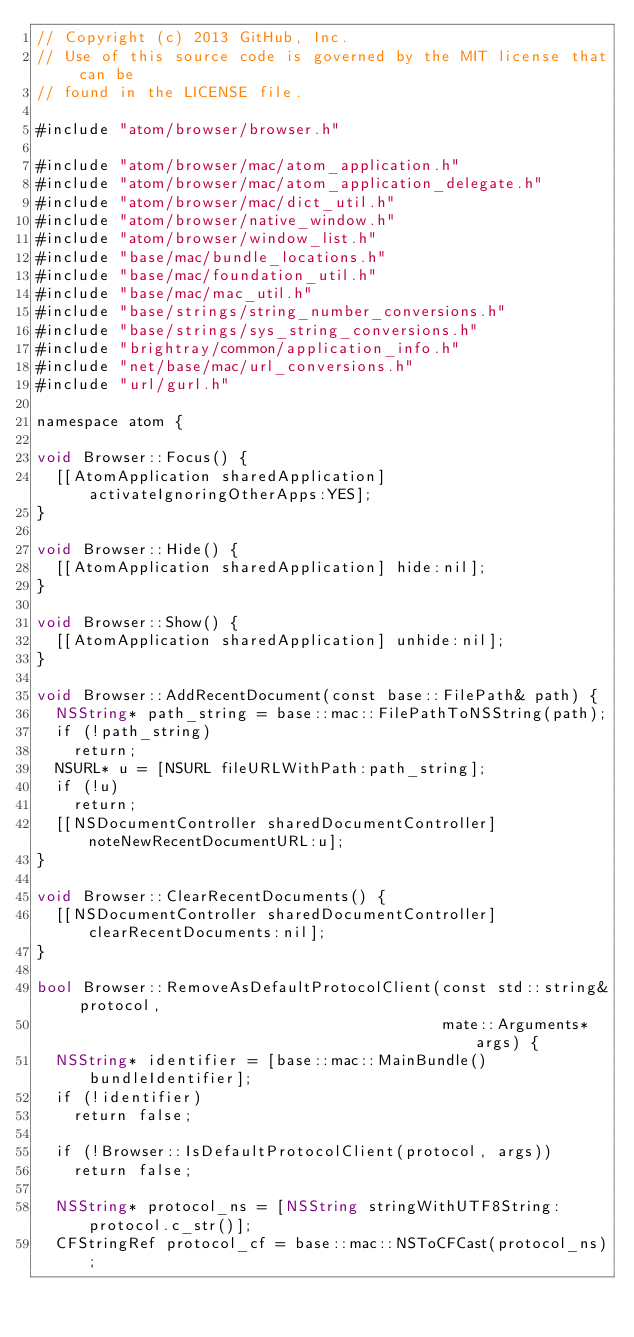<code> <loc_0><loc_0><loc_500><loc_500><_ObjectiveC_>// Copyright (c) 2013 GitHub, Inc.
// Use of this source code is governed by the MIT license that can be
// found in the LICENSE file.

#include "atom/browser/browser.h"

#include "atom/browser/mac/atom_application.h"
#include "atom/browser/mac/atom_application_delegate.h"
#include "atom/browser/mac/dict_util.h"
#include "atom/browser/native_window.h"
#include "atom/browser/window_list.h"
#include "base/mac/bundle_locations.h"
#include "base/mac/foundation_util.h"
#include "base/mac/mac_util.h"
#include "base/strings/string_number_conversions.h"
#include "base/strings/sys_string_conversions.h"
#include "brightray/common/application_info.h"
#include "net/base/mac/url_conversions.h"
#include "url/gurl.h"

namespace atom {

void Browser::Focus() {
  [[AtomApplication sharedApplication] activateIgnoringOtherApps:YES];
}

void Browser::Hide() {
  [[AtomApplication sharedApplication] hide:nil];
}

void Browser::Show() {
  [[AtomApplication sharedApplication] unhide:nil];
}

void Browser::AddRecentDocument(const base::FilePath& path) {
  NSString* path_string = base::mac::FilePathToNSString(path);
  if (!path_string)
    return;
  NSURL* u = [NSURL fileURLWithPath:path_string];
  if (!u)
    return;
  [[NSDocumentController sharedDocumentController] noteNewRecentDocumentURL:u];
}

void Browser::ClearRecentDocuments() {
  [[NSDocumentController sharedDocumentController] clearRecentDocuments:nil];
}

bool Browser::RemoveAsDefaultProtocolClient(const std::string& protocol,
                                            mate::Arguments* args) {
  NSString* identifier = [base::mac::MainBundle() bundleIdentifier];
  if (!identifier)
    return false;

  if (!Browser::IsDefaultProtocolClient(protocol, args))
    return false;

  NSString* protocol_ns = [NSString stringWithUTF8String:protocol.c_str()];
  CFStringRef protocol_cf = base::mac::NSToCFCast(protocol_ns);</code> 